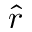<formula> <loc_0><loc_0><loc_500><loc_500>\hat { r }</formula> 